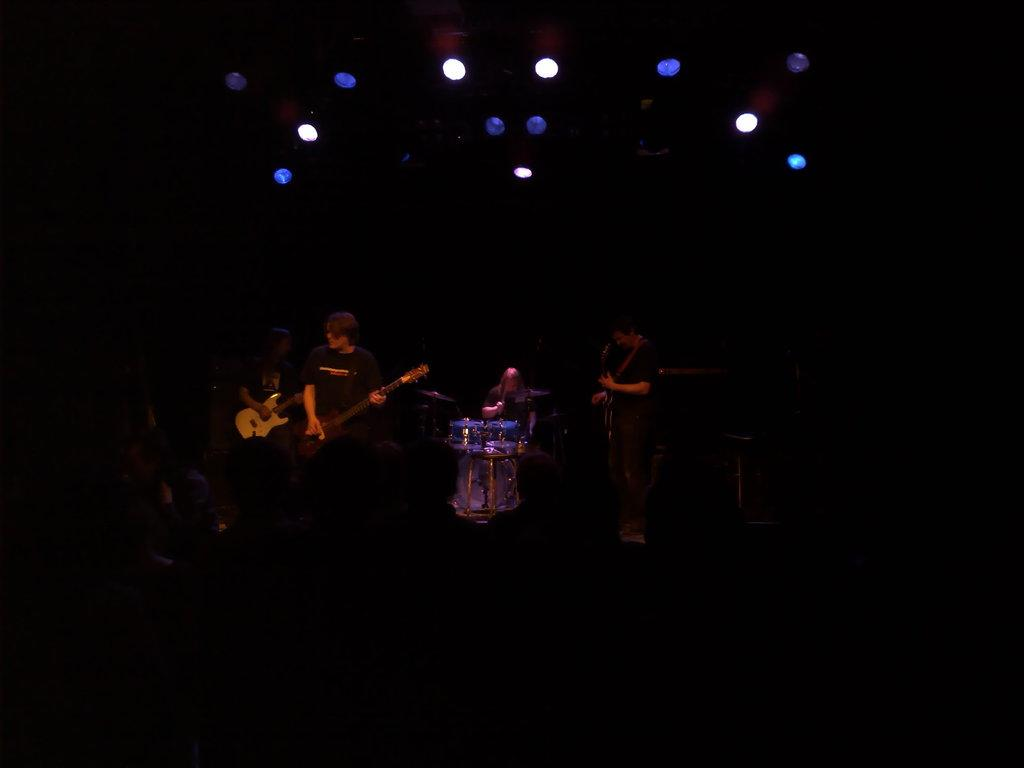What are the people in the image doing? Some people are playing guitars, while others are standing nearby. Can you describe the position of the sitting person in the image? The sitting person is playing a band. What type of instruments are being played in the image? Guitars are being played in the image. What can be seen at the top of the image? There are lights visible at the top of the image. What type of jelly is being used as a sound amplifier for the guitars in the image? There is no jelly present in the image, and it is not being used as a sound amplifier for the guitars. Can you tell me who won the competition between the guitar players in the image? There is no competition between the guitar players in the image. 